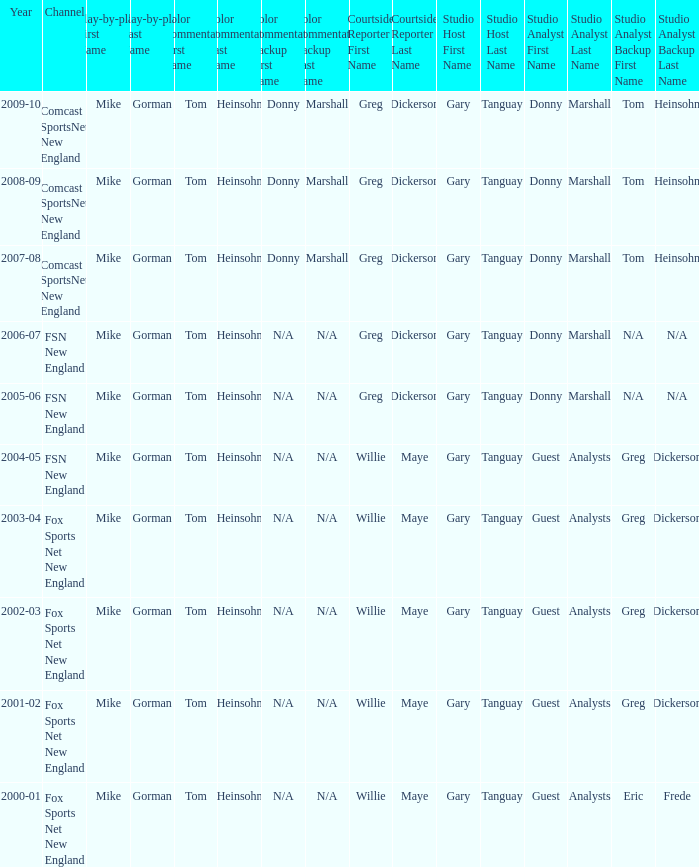Which Color commentator has a Channel of fsn new england, and a Year of 2004-05? Tom Heinsohn. 